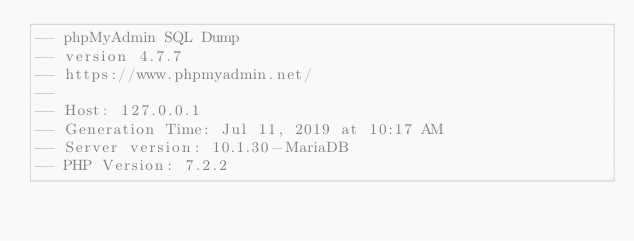Convert code to text. <code><loc_0><loc_0><loc_500><loc_500><_SQL_>-- phpMyAdmin SQL Dump
-- version 4.7.7
-- https://www.phpmyadmin.net/
--
-- Host: 127.0.0.1
-- Generation Time: Jul 11, 2019 at 10:17 AM
-- Server version: 10.1.30-MariaDB
-- PHP Version: 7.2.2
</code> 